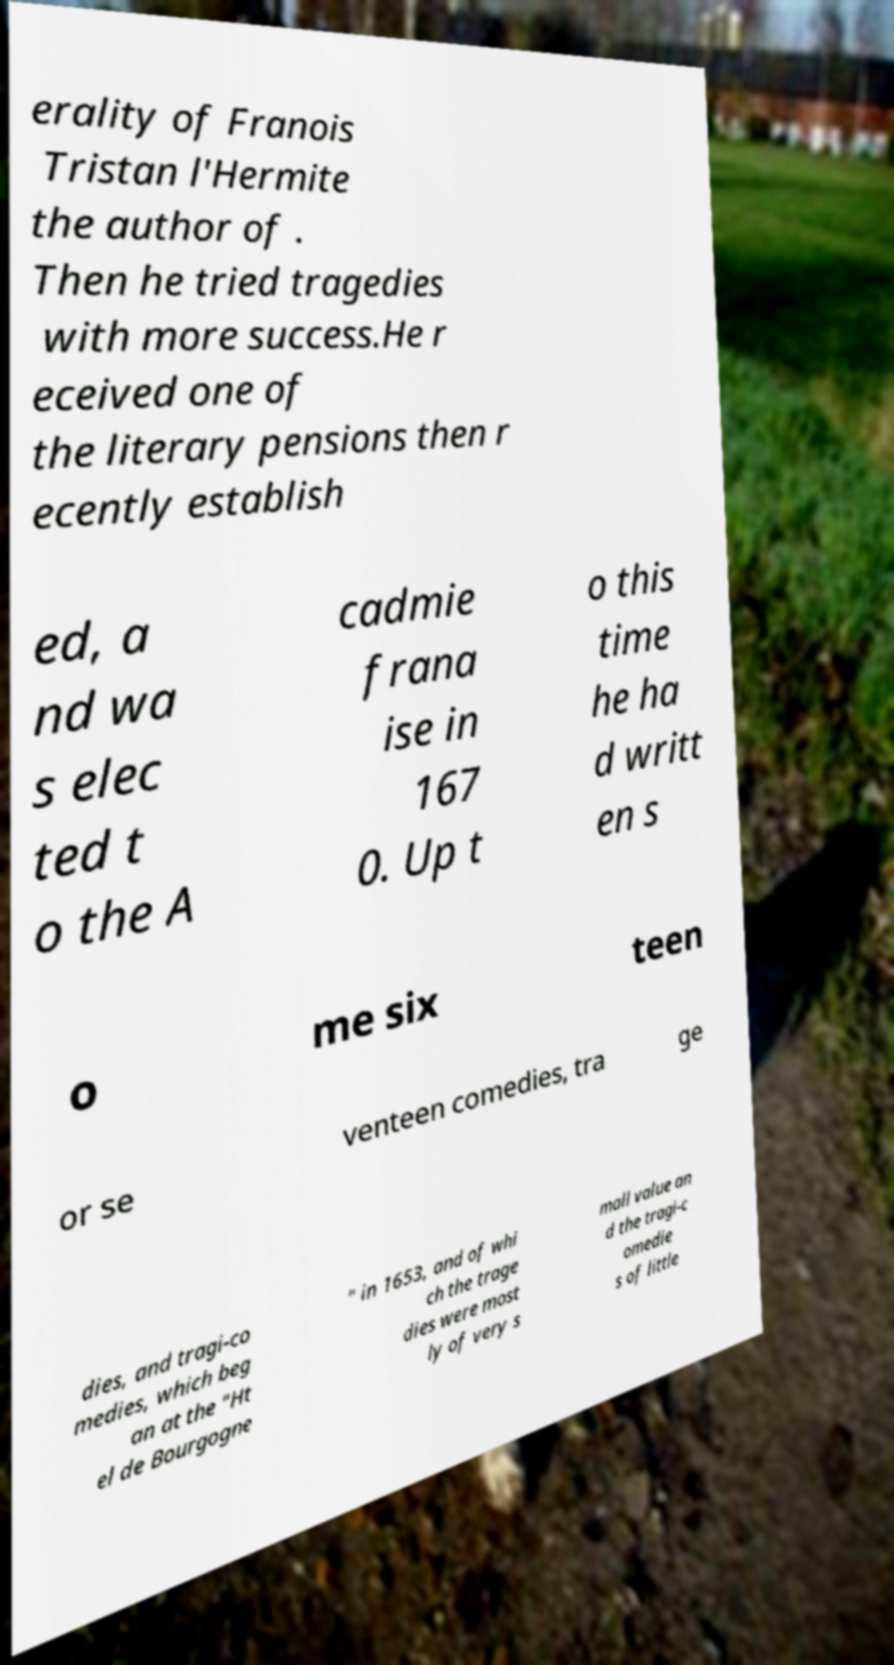Please read and relay the text visible in this image. What does it say? erality of Franois Tristan l'Hermite the author of . Then he tried tragedies with more success.He r eceived one of the literary pensions then r ecently establish ed, a nd wa s elec ted t o the A cadmie frana ise in 167 0. Up t o this time he ha d writt en s o me six teen or se venteen comedies, tra ge dies, and tragi-co medies, which beg an at the "Ht el de Bourgogne " in 1653, and of whi ch the trage dies were most ly of very s mall value an d the tragi-c omedie s of little 